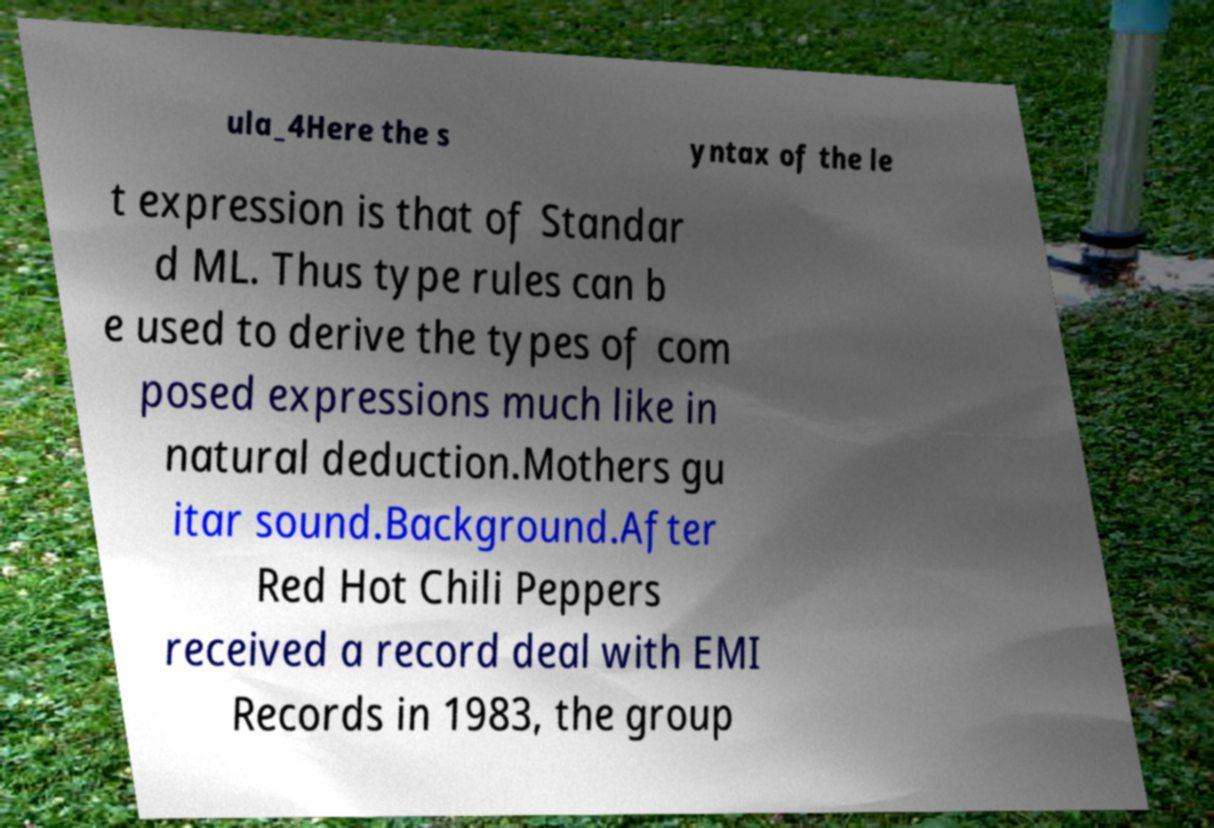I need the written content from this picture converted into text. Can you do that? ula_4Here the s yntax of the le t expression is that of Standar d ML. Thus type rules can b e used to derive the types of com posed expressions much like in natural deduction.Mothers gu itar sound.Background.After Red Hot Chili Peppers received a record deal with EMI Records in 1983, the group 